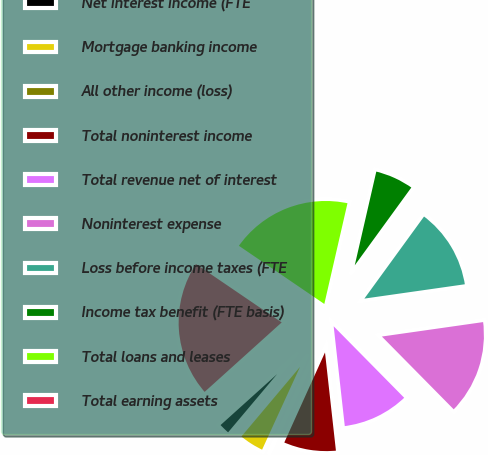<chart> <loc_0><loc_0><loc_500><loc_500><pie_chart><fcel>Net interest income (FTE<fcel>Mortgage banking income<fcel>All other income (loss)<fcel>Total noninterest income<fcel>Total revenue net of interest<fcel>Noninterest expense<fcel>Loss before income taxes (FTE<fcel>Income tax benefit (FTE basis)<fcel>Total loans and leases<fcel>Total earning assets<nl><fcel>2.19%<fcel>4.3%<fcel>0.08%<fcel>8.52%<fcel>10.63%<fcel>14.86%<fcel>12.74%<fcel>6.41%<fcel>19.08%<fcel>21.19%<nl></chart> 